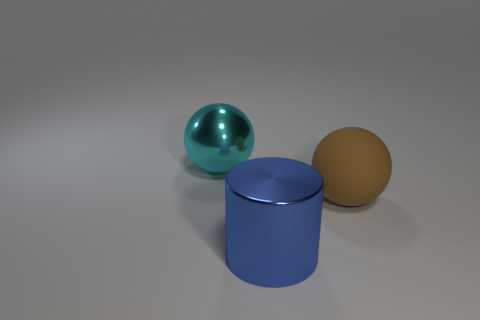What is the large sphere that is on the left side of the ball right of the shiny thing behind the cylinder made of? The large sphere to the left in the image appears to be made of a glossy material, likely metal or a reflective plastic, evidenced by the clear highlights and reflections on its surface, which are characteristic of such materials. 